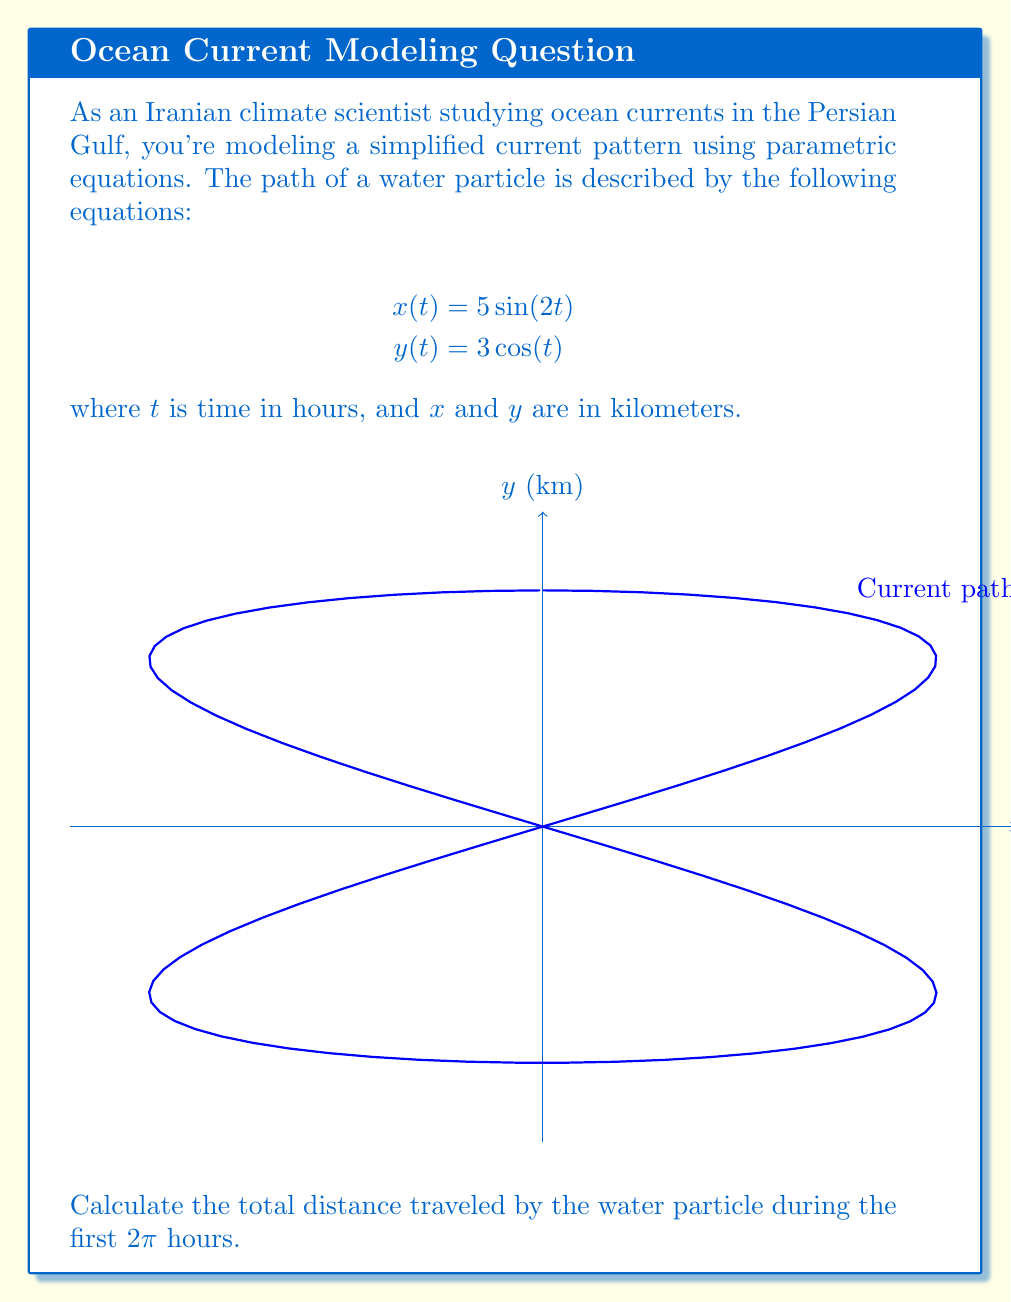Help me with this question. To solve this problem, we'll follow these steps:

1) The distance traveled along a parametric curve is given by the arc length formula:

   $$L = \int_a^b \sqrt{\left(\frac{dx}{dt}\right)^2 + \left(\frac{dy}{dt}\right)^2} dt$$

2) First, let's find $\frac{dx}{dt}$ and $\frac{dy}{dt}$:
   
   $$\frac{dx}{dt} = 10\cos(2t)$$
   $$\frac{dy}{dt} = -3\sin(t)$$

3) Now, let's substitute these into the arc length formula:

   $$L = \int_0^{2\pi} \sqrt{(10\cos(2t))^2 + (-3\sin(t))^2} dt$$

4) Simplify under the square root:

   $$L = \int_0^{2\pi} \sqrt{100\cos^2(2t) + 9\sin^2(t)} dt$$

5) This integral is complex and doesn't have a simple analytical solution. We need to use numerical integration methods to approximate it.

6) Using a computational tool (like Python with SciPy), we can numerically evaluate this integral:

   ```python
   from scipy import integrate
   import numpy as np

   def integrand(t):
       return np.sqrt(100 * np.cos(2*t)**2 + 9 * np.sin(t)**2)

   result, _ = integrate.quad(integrand, 0, 2*np.pi)
   print(result)
   ```

7) The result of this numerical integration is approximately 44.42 km.
Answer: 44.42 km 